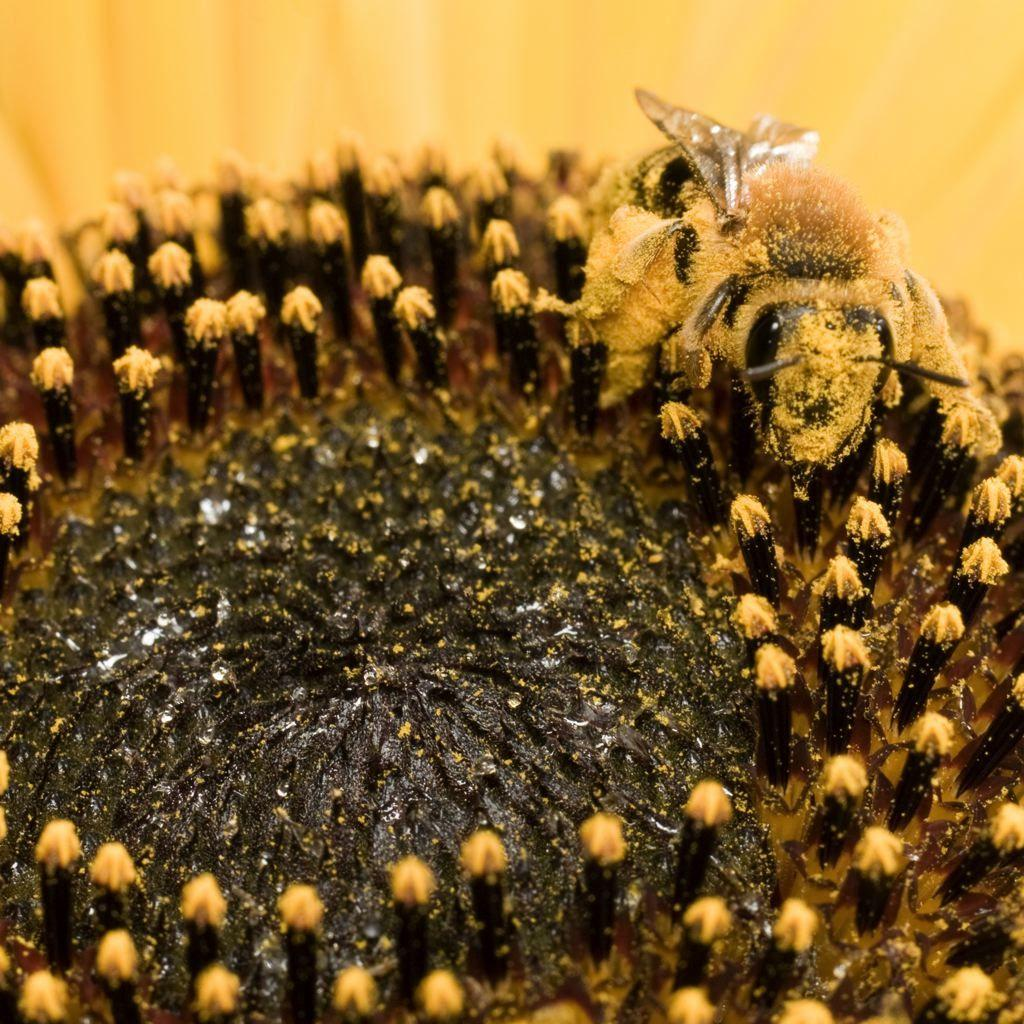What is present on the flower in the image? There is an insect on the flower in the image. What can be said about the color of the flower? The flower is in brown and yellow color. What is the color of the insect in the image? The insect is in brown and black color. How many ants can be seen carrying nuts on the railway in the image? There are no ants, nuts, or railway present in the image. The image features an insect on a flower with specific colors. 